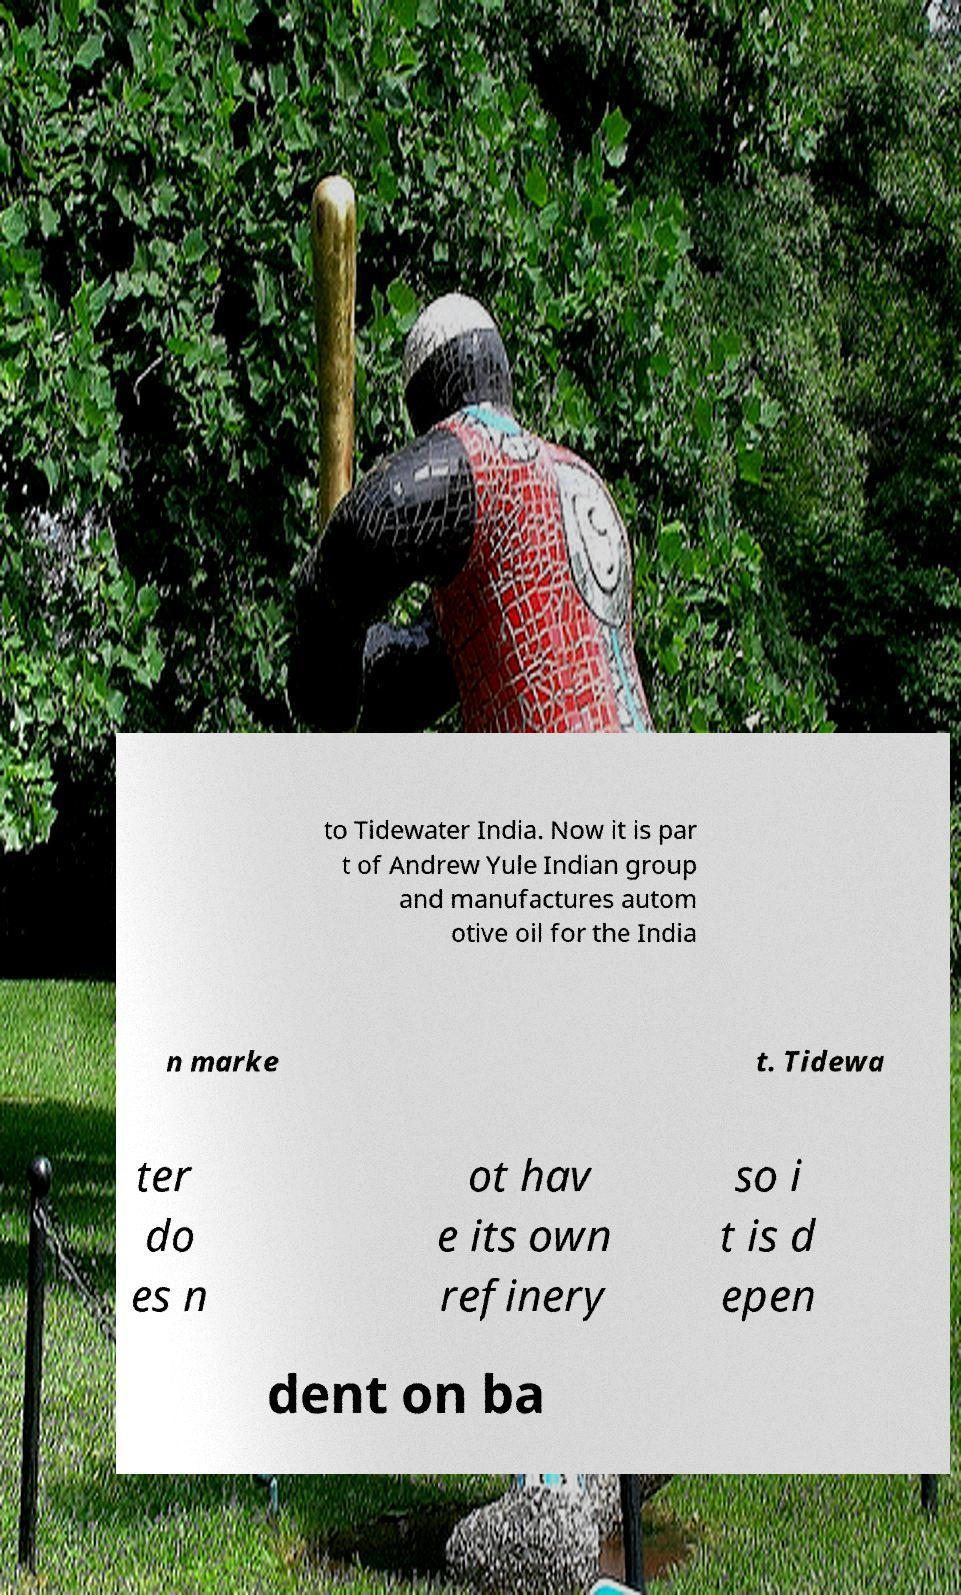Can you read and provide the text displayed in the image?This photo seems to have some interesting text. Can you extract and type it out for me? to Tidewater India. Now it is par t of Andrew Yule Indian group and manufactures autom otive oil for the India n marke t. Tidewa ter do es n ot hav e its own refinery so i t is d epen dent on ba 